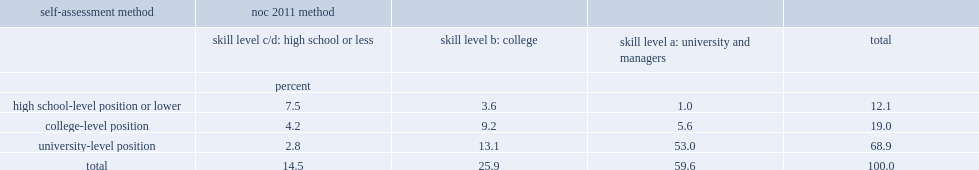What was the percentage of university graduates working in occupations requiring a high school diploma or less education. 14.5. Among the 12% who were found to be overqualified using the self-assessment,what was the percentage of those who would have been overqualified. 7.5. Among the 69% who considered themselves as having a job requiring a university education,what was the percentage of those overqualified ? 2.8. 